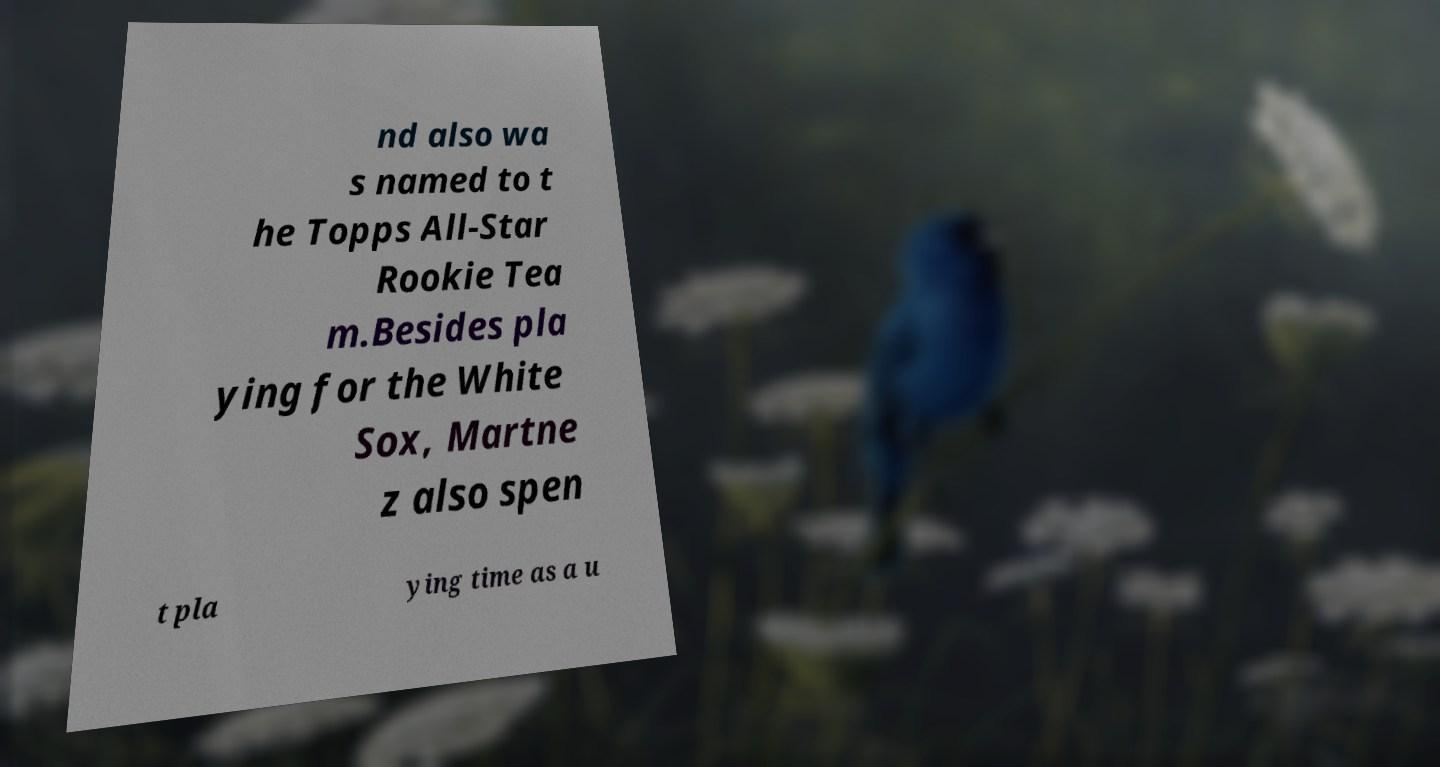I need the written content from this picture converted into text. Can you do that? nd also wa s named to t he Topps All-Star Rookie Tea m.Besides pla ying for the White Sox, Martne z also spen t pla ying time as a u 